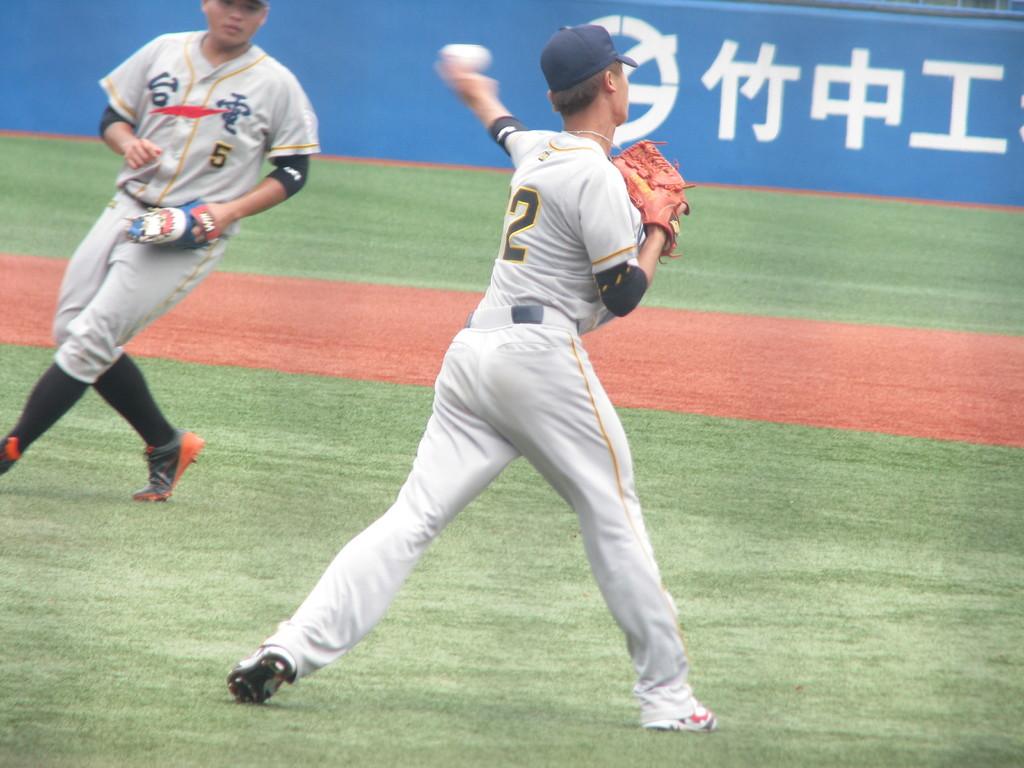Which number is visible on the back of the man throwing the ball?
Your answer should be compact. 2. What number is on the mans shirt to the left?
Provide a short and direct response. 5. 